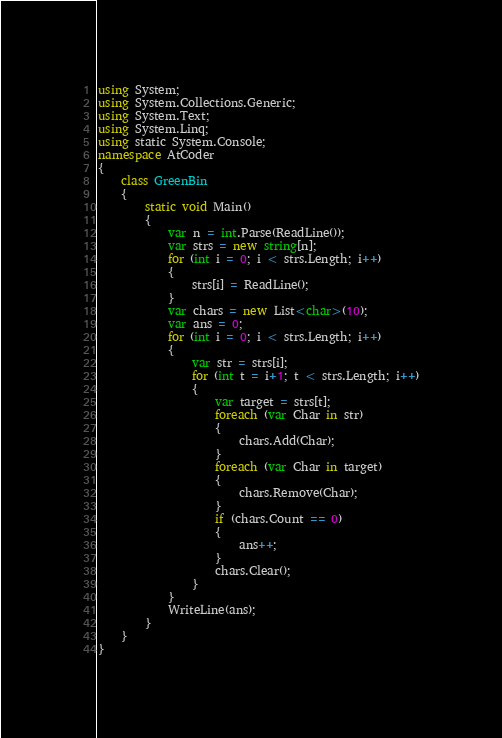Convert code to text. <code><loc_0><loc_0><loc_500><loc_500><_C#_>using System;
using System.Collections.Generic;
using System.Text;
using System.Linq;
using static System.Console;
namespace AtCoder
{
    class GreenBin
    {
        static void Main()
        {
            var n = int.Parse(ReadLine());
            var strs = new string[n];
            for (int i = 0; i < strs.Length; i++)
            {
                strs[i] = ReadLine();
            }
            var chars = new List<char>(10);
            var ans = 0;
            for (int i = 0; i < strs.Length; i++)
            {
                var str = strs[i];
                for (int t = i+1; t < strs.Length; i++)
                {
                    var target = strs[t];
                    foreach (var Char in str)
                    {
                        chars.Add(Char);
                    }
                    foreach (var Char in target)
                    {
                        chars.Remove(Char);
                    }
                    if (chars.Count == 0)
                    {
                        ans++;
                    }
                    chars.Clear();
                }
            }
            WriteLine(ans);
        }
    }
}
</code> 